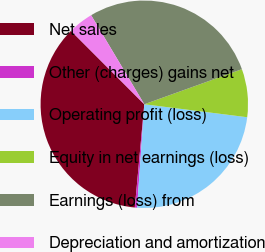Convert chart. <chart><loc_0><loc_0><loc_500><loc_500><pie_chart><fcel>Net sales<fcel>Other (charges) gains net<fcel>Operating profit (loss)<fcel>Equity in net earnings (loss)<fcel>Earnings (loss) from<fcel>Depreciation and amortization<nl><fcel>36.06%<fcel>0.35%<fcel>24.11%<fcel>7.49%<fcel>28.08%<fcel>3.92%<nl></chart> 